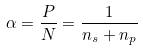Convert formula to latex. <formula><loc_0><loc_0><loc_500><loc_500>\alpha = \frac { P } { N } = \frac { 1 } { n _ { s } + n _ { p } }</formula> 